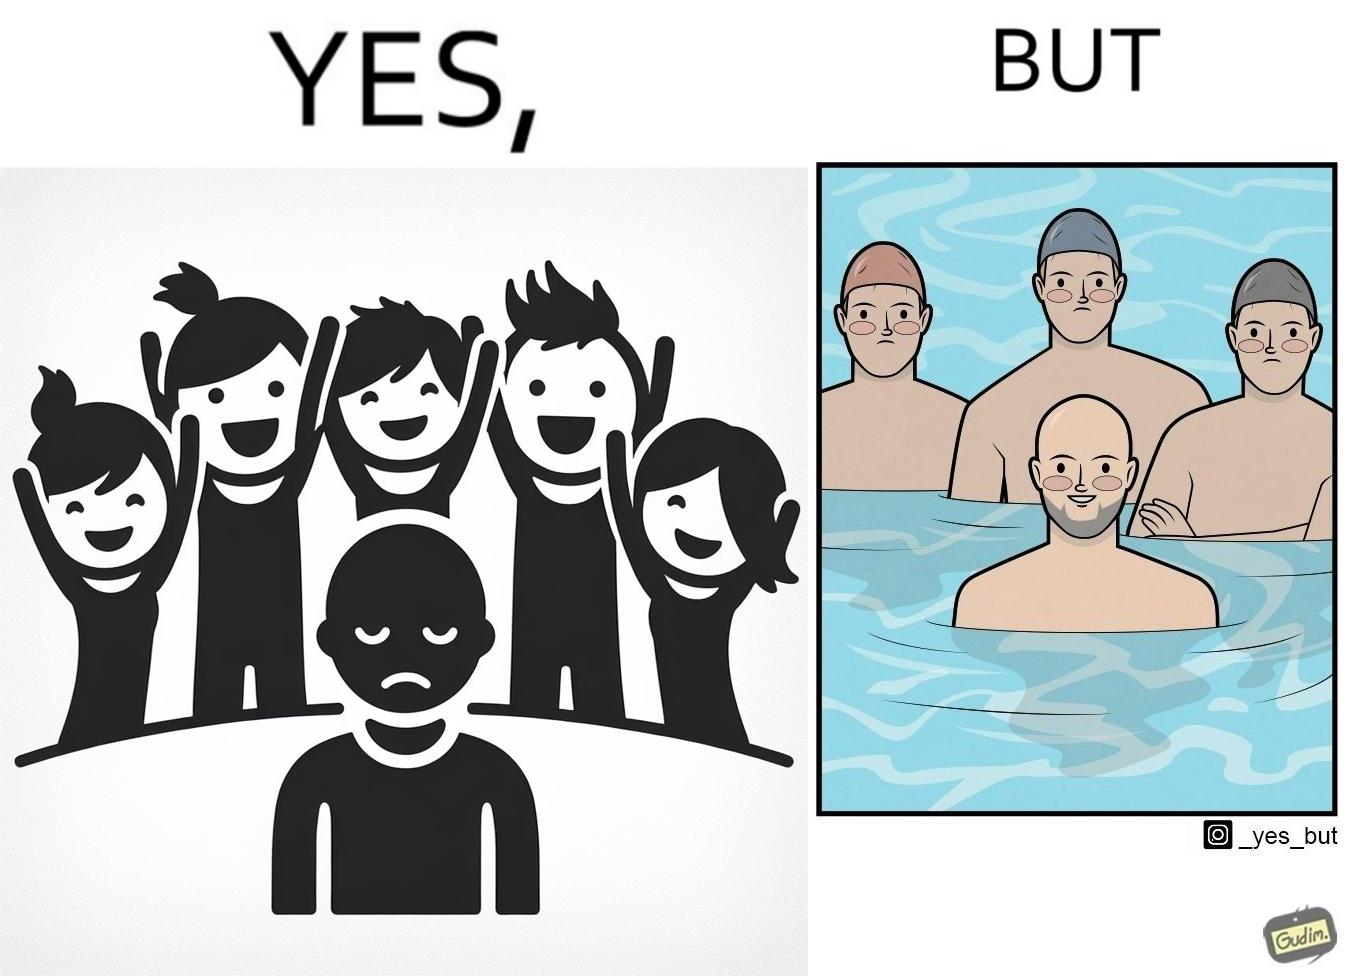Is there satirical content in this image? Yes, this image is satirical. 